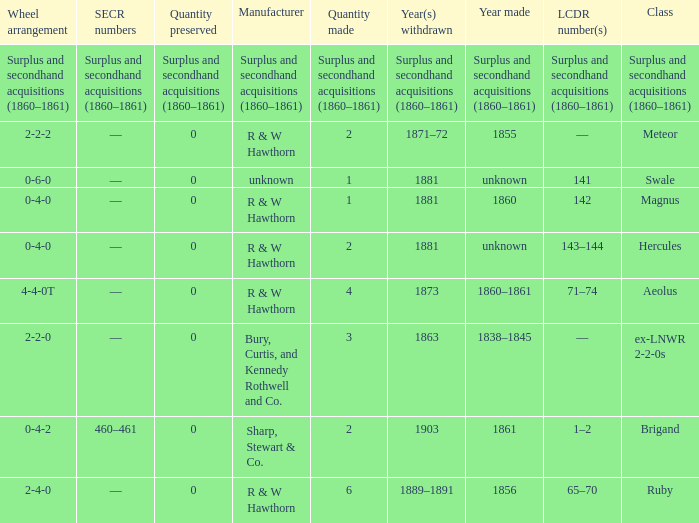What was the SECR number of the item made in 1861? 460–461. 